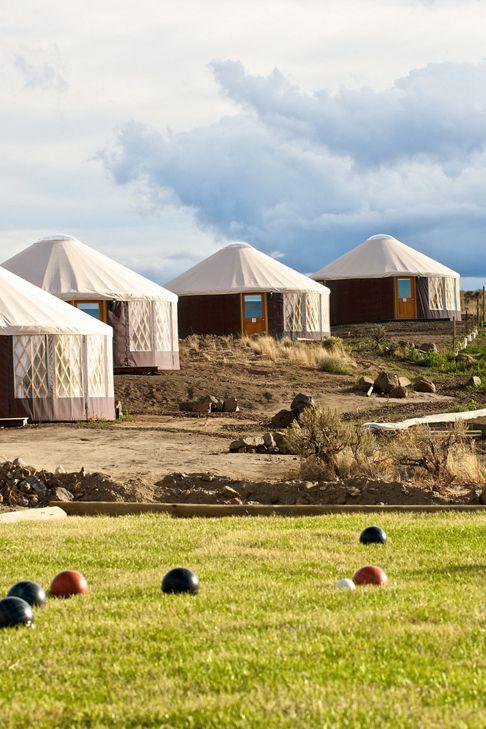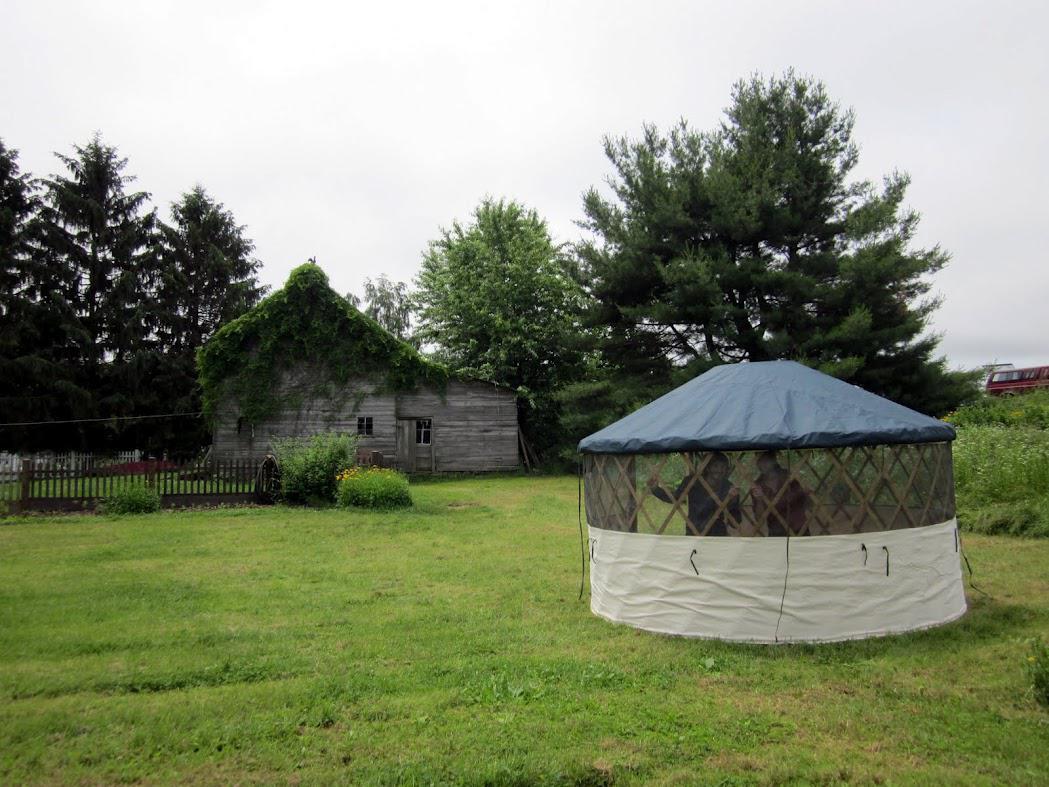The first image is the image on the left, the second image is the image on the right. Evaluate the accuracy of this statement regarding the images: "At least one image contains 3 or more yurts.". Is it true? Answer yes or no. Yes. 